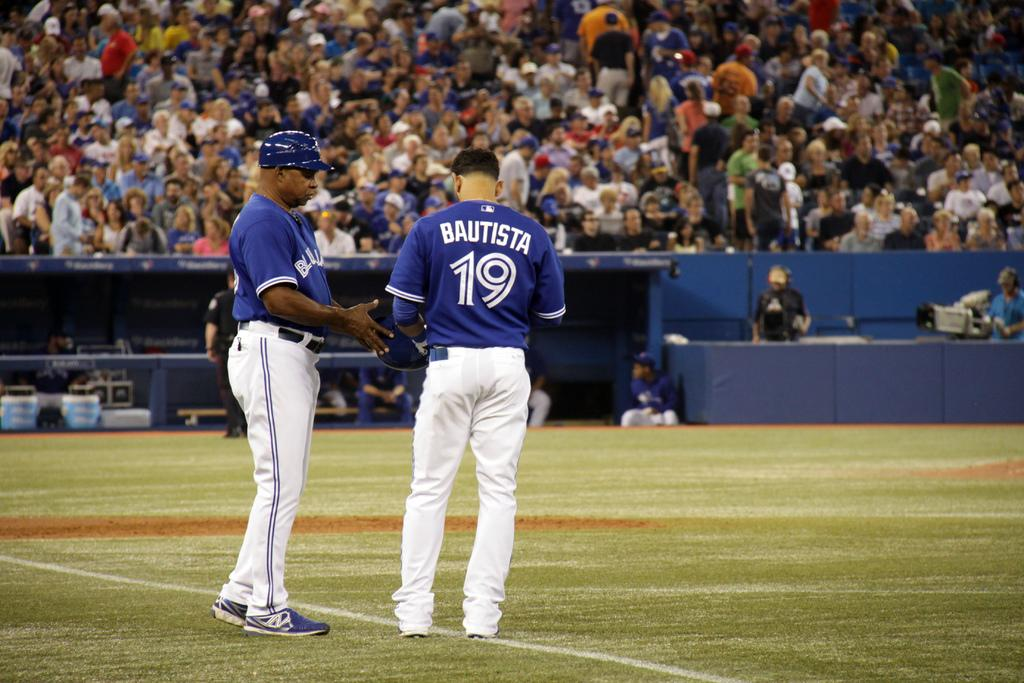<image>
Offer a succinct explanation of the picture presented. Bautista is player number 19 on his baseball team. 